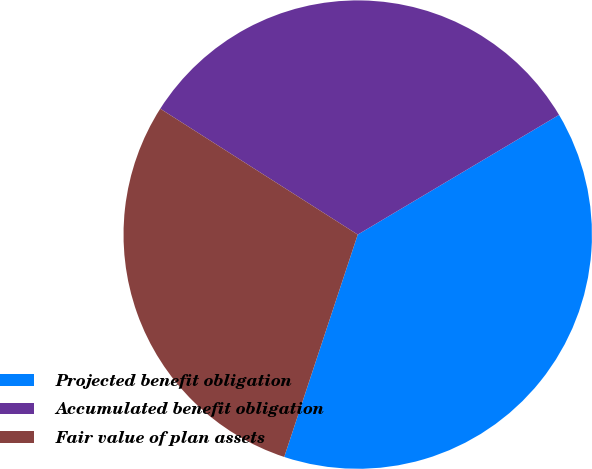Convert chart. <chart><loc_0><loc_0><loc_500><loc_500><pie_chart><fcel>Projected benefit obligation<fcel>Accumulated benefit obligation<fcel>Fair value of plan assets<nl><fcel>38.62%<fcel>32.43%<fcel>28.95%<nl></chart> 